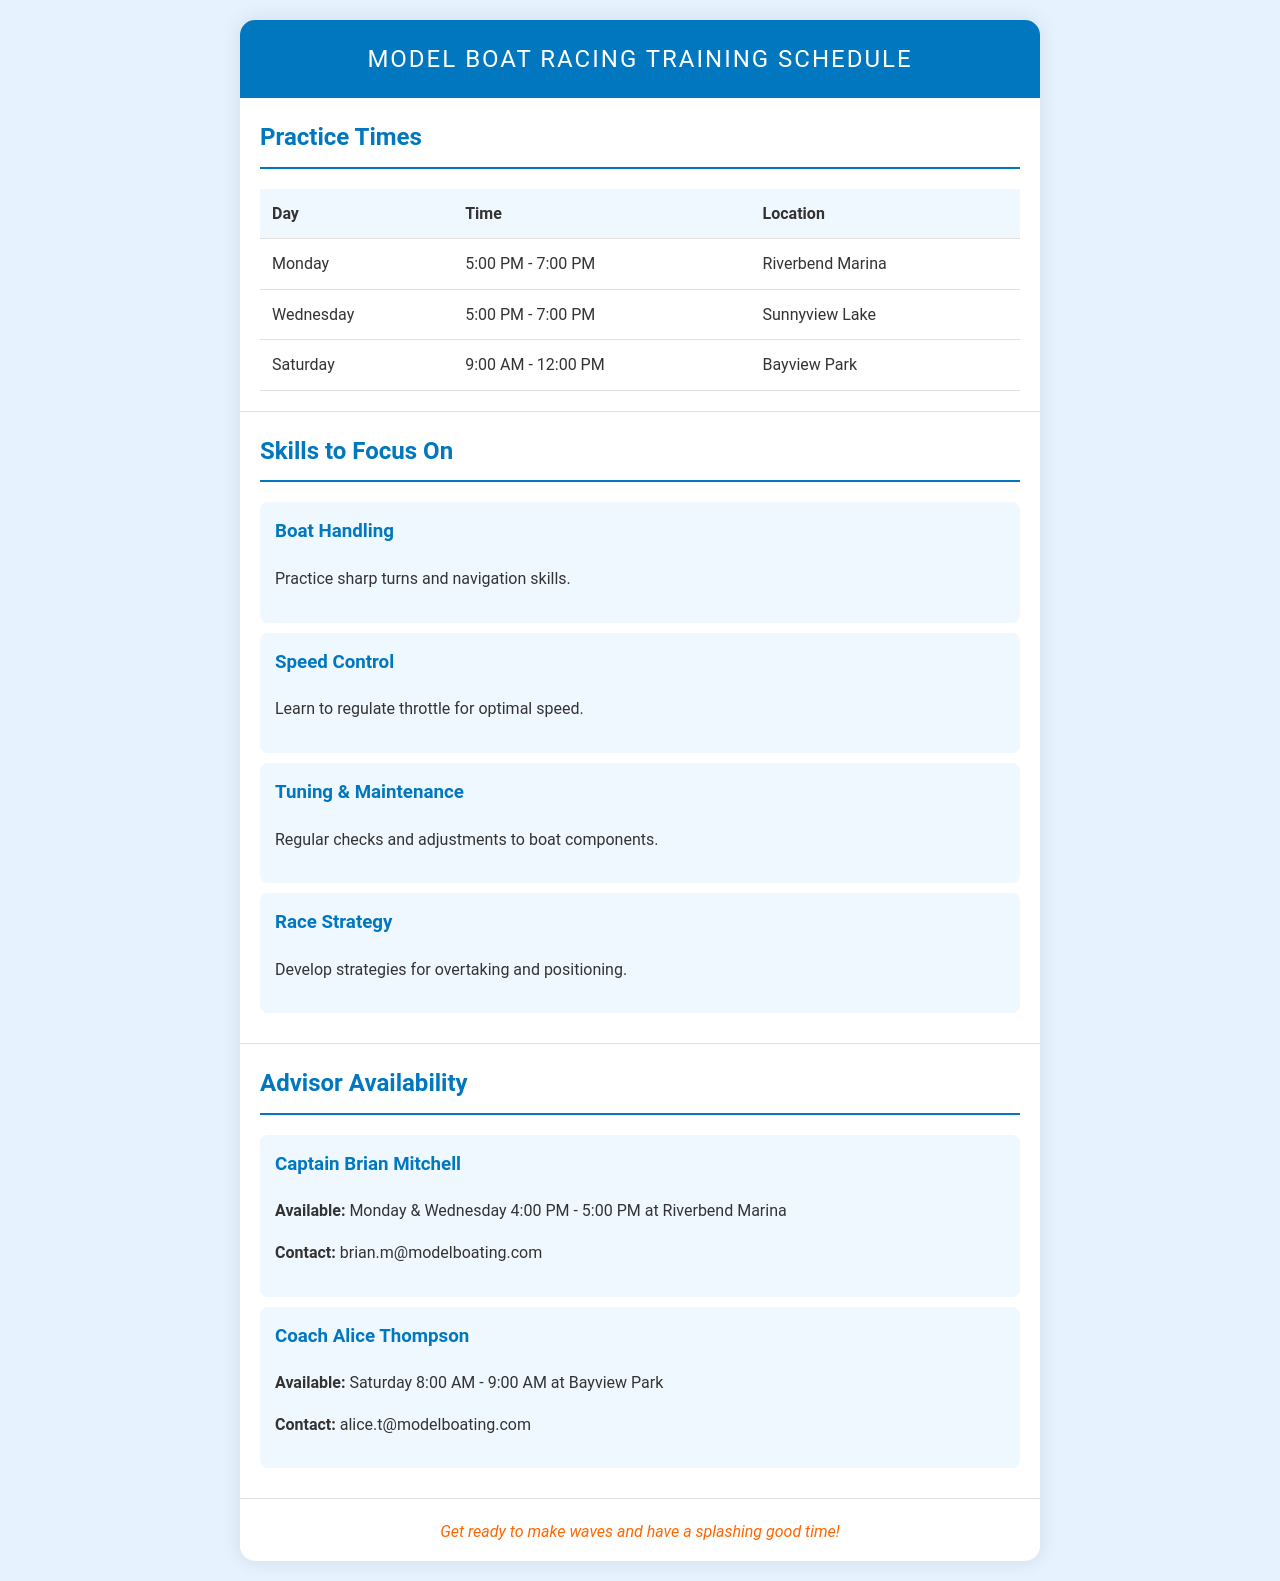What are the practice times on Monday? The schedule lists practice times for each day, including Monday from 5:00 PM to 7:00 PM.
Answer: 5:00 PM - 7:00 PM Where is the practice held on Saturday? The document specifies Bayview Park as the location for practice on Saturday.
Answer: Bayview Park What skill focuses on navigation? The section on skills to focus on includes "Boat Handling," which involves navigation skills.
Answer: Boat Handling Who is available for advice on Monday? The advisor availability section indicates Captain Brian Mitchell is available on Monday.
Answer: Captain Brian Mitchell What time does Coach Alice Thompson start on Saturday? The availability of Coach Alice Thompson states she is available starting at 8:00 AM on Saturday.
Answer: 8:00 AM What is one skill to develop for racing strategy? "Race Strategy" is mentioned as a skill to develop, focused on overtaking.
Answer: Race Strategy What day does the advisor availability mention is the only one for Coach Alice Thompson? The document specifies that Coach Alice Thompson is only available on Saturday for advice.
Answer: Saturday What is the ending time for practice on Wednesday? The schedule indicates practice ends at 7:00 PM on Wednesday.
Answer: 7:00 PM 